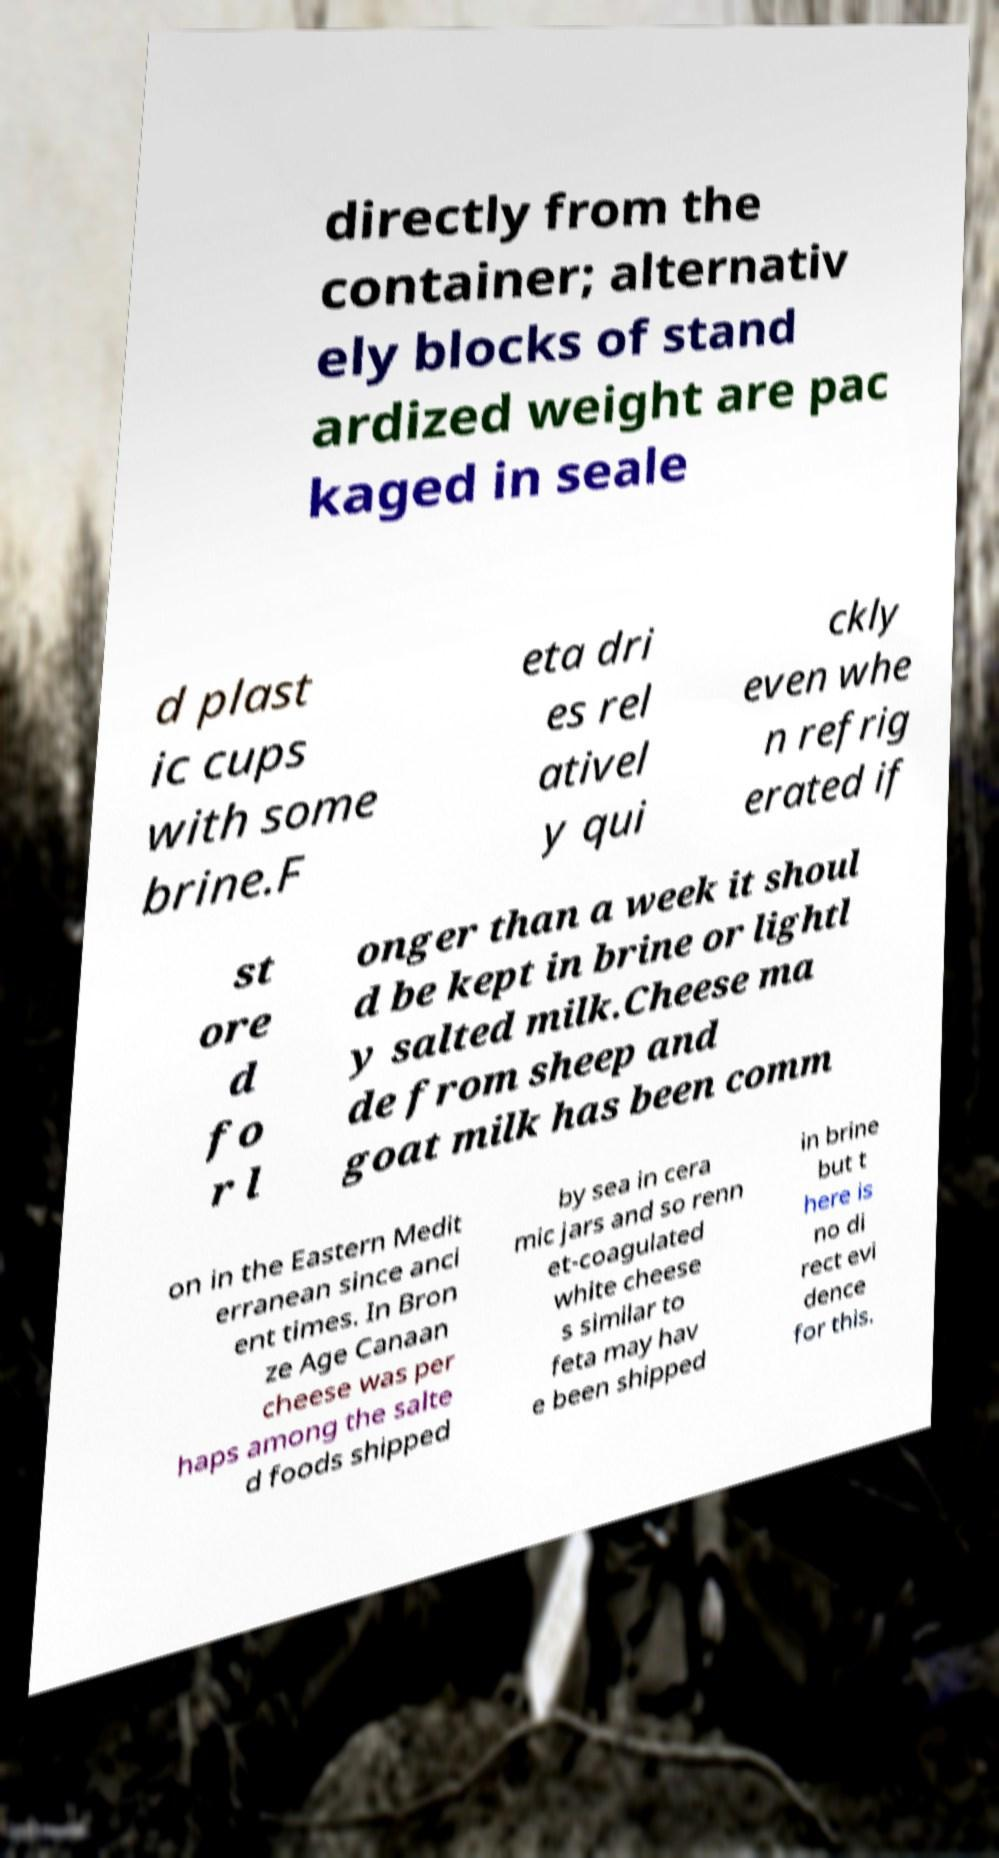For documentation purposes, I need the text within this image transcribed. Could you provide that? directly from the container; alternativ ely blocks of stand ardized weight are pac kaged in seale d plast ic cups with some brine.F eta dri es rel ativel y qui ckly even whe n refrig erated if st ore d fo r l onger than a week it shoul d be kept in brine or lightl y salted milk.Cheese ma de from sheep and goat milk has been comm on in the Eastern Medit erranean since anci ent times. In Bron ze Age Canaan cheese was per haps among the salte d foods shipped by sea in cera mic jars and so renn et-coagulated white cheese s similar to feta may hav e been shipped in brine but t here is no di rect evi dence for this. 